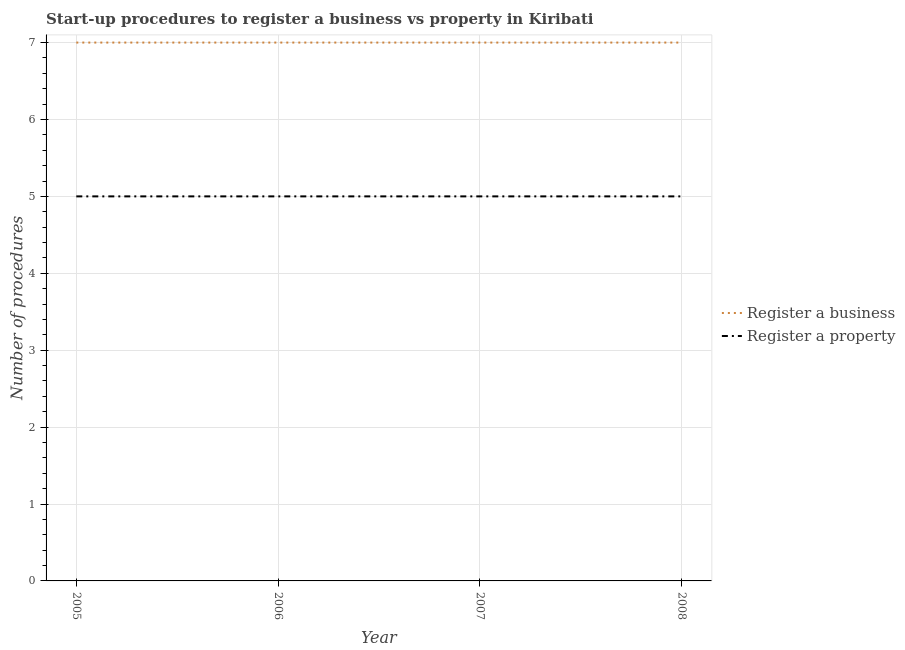What is the number of procedures to register a business in 2006?
Ensure brevity in your answer.  7. Across all years, what is the maximum number of procedures to register a property?
Make the answer very short. 5. Across all years, what is the minimum number of procedures to register a business?
Ensure brevity in your answer.  7. In which year was the number of procedures to register a property maximum?
Offer a very short reply. 2005. In which year was the number of procedures to register a property minimum?
Provide a short and direct response. 2005. What is the total number of procedures to register a business in the graph?
Provide a succinct answer. 28. What is the difference between the number of procedures to register a business in 2005 and that in 2008?
Offer a terse response. 0. What is the difference between the number of procedures to register a business in 2005 and the number of procedures to register a property in 2007?
Your answer should be compact. 2. In the year 2005, what is the difference between the number of procedures to register a property and number of procedures to register a business?
Keep it short and to the point. -2. In how many years, is the number of procedures to register a business greater than 5.6?
Give a very brief answer. 4. What is the ratio of the number of procedures to register a property in 2006 to that in 2007?
Make the answer very short. 1. Is the difference between the number of procedures to register a business in 2006 and 2008 greater than the difference between the number of procedures to register a property in 2006 and 2008?
Give a very brief answer. No. In how many years, is the number of procedures to register a business greater than the average number of procedures to register a business taken over all years?
Ensure brevity in your answer.  0. Is the sum of the number of procedures to register a property in 2007 and 2008 greater than the maximum number of procedures to register a business across all years?
Keep it short and to the point. Yes. Does the number of procedures to register a property monotonically increase over the years?
Your answer should be compact. No. How many lines are there?
Ensure brevity in your answer.  2. How many years are there in the graph?
Make the answer very short. 4. What is the difference between two consecutive major ticks on the Y-axis?
Offer a very short reply. 1. Are the values on the major ticks of Y-axis written in scientific E-notation?
Keep it short and to the point. No. Does the graph contain any zero values?
Provide a succinct answer. No. Does the graph contain grids?
Give a very brief answer. Yes. Where does the legend appear in the graph?
Make the answer very short. Center right. What is the title of the graph?
Give a very brief answer. Start-up procedures to register a business vs property in Kiribati. What is the label or title of the Y-axis?
Give a very brief answer. Number of procedures. What is the Number of procedures of Register a business in 2005?
Offer a very short reply. 7. What is the Number of procedures in Register a property in 2005?
Give a very brief answer. 5. What is the Number of procedures in Register a property in 2006?
Provide a succinct answer. 5. What is the Number of procedures of Register a property in 2007?
Your response must be concise. 5. What is the Number of procedures in Register a business in 2008?
Provide a succinct answer. 7. What is the Number of procedures of Register a property in 2008?
Your answer should be very brief. 5. Across all years, what is the maximum Number of procedures of Register a property?
Make the answer very short. 5. Across all years, what is the minimum Number of procedures in Register a business?
Give a very brief answer. 7. What is the difference between the Number of procedures of Register a business in 2005 and that in 2007?
Give a very brief answer. 0. What is the difference between the Number of procedures in Register a property in 2005 and that in 2007?
Keep it short and to the point. 0. What is the difference between the Number of procedures of Register a business in 2006 and that in 2007?
Offer a terse response. 0. What is the difference between the Number of procedures of Register a business in 2006 and that in 2008?
Provide a succinct answer. 0. What is the difference between the Number of procedures of Register a business in 2007 and that in 2008?
Provide a succinct answer. 0. What is the difference between the Number of procedures of Register a business in 2005 and the Number of procedures of Register a property in 2006?
Offer a terse response. 2. What is the difference between the Number of procedures in Register a business in 2005 and the Number of procedures in Register a property in 2008?
Offer a very short reply. 2. What is the difference between the Number of procedures in Register a business in 2006 and the Number of procedures in Register a property in 2008?
Provide a succinct answer. 2. What is the average Number of procedures of Register a property per year?
Your response must be concise. 5. In the year 2005, what is the difference between the Number of procedures of Register a business and Number of procedures of Register a property?
Provide a short and direct response. 2. In the year 2006, what is the difference between the Number of procedures of Register a business and Number of procedures of Register a property?
Offer a very short reply. 2. What is the ratio of the Number of procedures of Register a business in 2005 to that in 2006?
Offer a very short reply. 1. What is the ratio of the Number of procedures in Register a property in 2005 to that in 2006?
Your answer should be compact. 1. What is the ratio of the Number of procedures of Register a property in 2005 to that in 2007?
Your response must be concise. 1. What is the ratio of the Number of procedures in Register a property in 2005 to that in 2008?
Your answer should be compact. 1. What is the ratio of the Number of procedures of Register a business in 2006 to that in 2007?
Make the answer very short. 1. What is the ratio of the Number of procedures of Register a property in 2006 to that in 2007?
Make the answer very short. 1. What is the ratio of the Number of procedures of Register a property in 2007 to that in 2008?
Ensure brevity in your answer.  1. What is the difference between the highest and the second highest Number of procedures of Register a business?
Keep it short and to the point. 0. What is the difference between the highest and the lowest Number of procedures of Register a business?
Give a very brief answer. 0. What is the difference between the highest and the lowest Number of procedures in Register a property?
Provide a short and direct response. 0. 